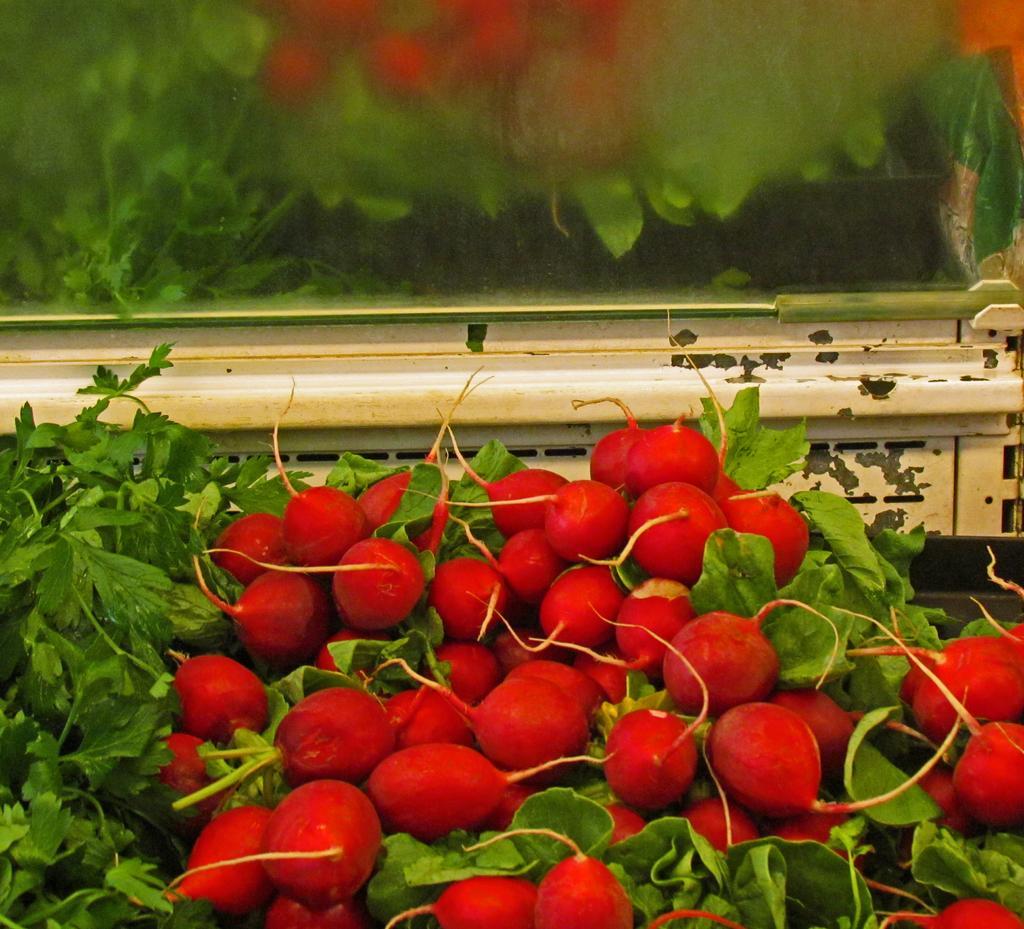How would you summarize this image in a sentence or two? In this image at the bottom there are some fruits and some leaves. In the background it looks like a glass mirror, in the mirror there is a reflection of some fruits and plants. 